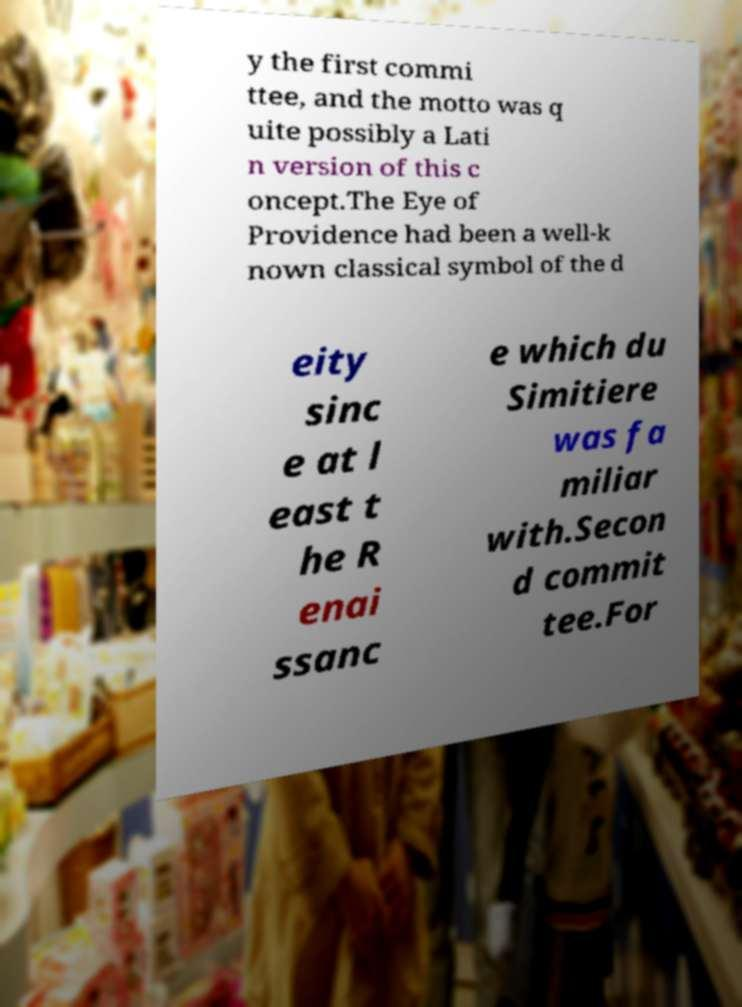Can you accurately transcribe the text from the provided image for me? y the first commi ttee, and the motto was q uite possibly a Lati n version of this c oncept.The Eye of Providence had been a well-k nown classical symbol of the d eity sinc e at l east t he R enai ssanc e which du Simitiere was fa miliar with.Secon d commit tee.For 